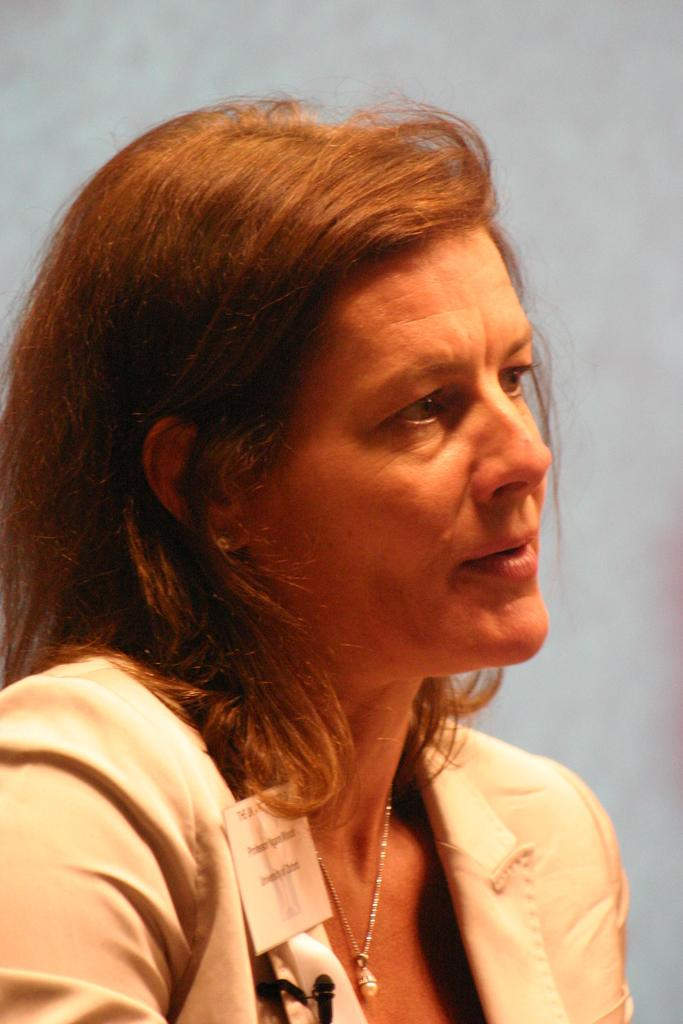Who is the main subject in the image? There is a woman in the image. What is the woman doing in the image? The woman is looking to the right side of the image. Can you describe the background of the image? The background of the image is blurred. What type of steam is coming out of the woman's ears in the image? There is no steam coming out of the woman's ears in the image; her ears are not visible. 